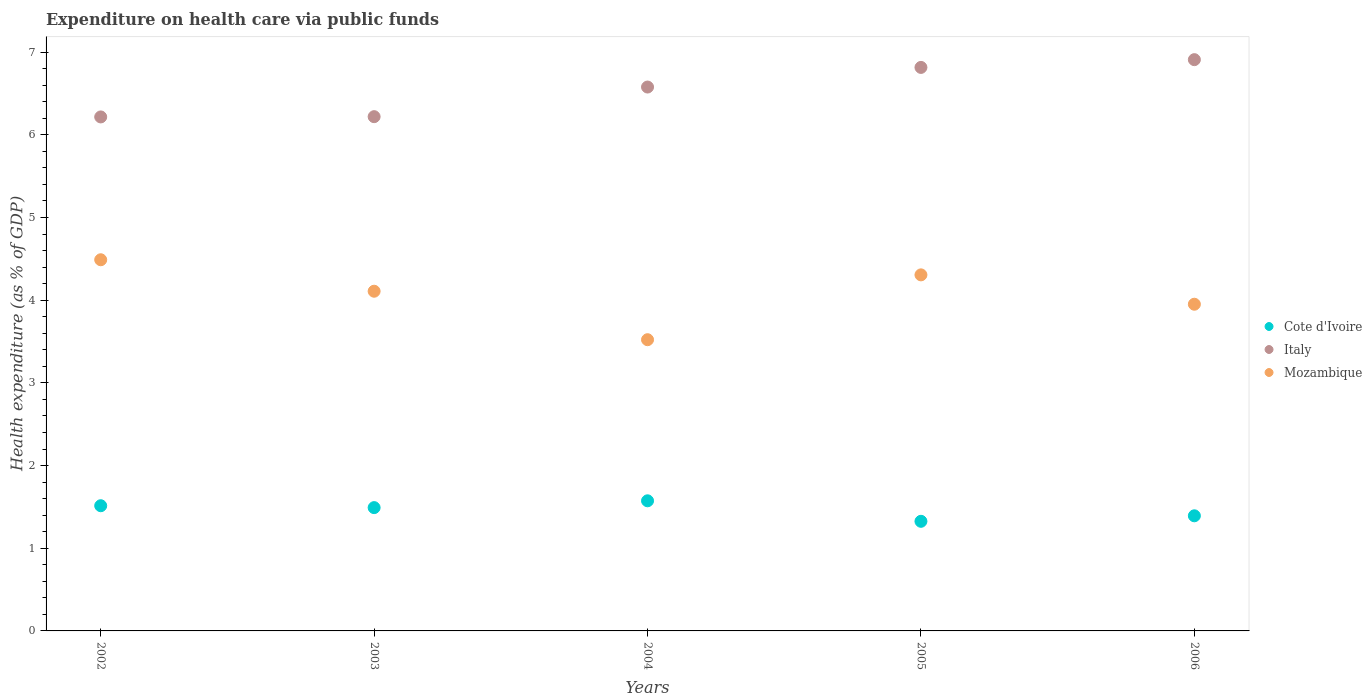Is the number of dotlines equal to the number of legend labels?
Your answer should be compact. Yes. What is the expenditure made on health care in Italy in 2002?
Keep it short and to the point. 6.22. Across all years, what is the maximum expenditure made on health care in Cote d'Ivoire?
Offer a terse response. 1.57. Across all years, what is the minimum expenditure made on health care in Cote d'Ivoire?
Your answer should be compact. 1.33. In which year was the expenditure made on health care in Cote d'Ivoire maximum?
Offer a terse response. 2004. In which year was the expenditure made on health care in Italy minimum?
Provide a short and direct response. 2002. What is the total expenditure made on health care in Mozambique in the graph?
Offer a terse response. 20.38. What is the difference between the expenditure made on health care in Italy in 2002 and that in 2006?
Give a very brief answer. -0.69. What is the difference between the expenditure made on health care in Mozambique in 2004 and the expenditure made on health care in Italy in 2005?
Keep it short and to the point. -3.29. What is the average expenditure made on health care in Italy per year?
Keep it short and to the point. 6.55. In the year 2003, what is the difference between the expenditure made on health care in Cote d'Ivoire and expenditure made on health care in Italy?
Offer a terse response. -4.73. In how many years, is the expenditure made on health care in Mozambique greater than 3 %?
Your answer should be very brief. 5. What is the ratio of the expenditure made on health care in Cote d'Ivoire in 2002 to that in 2006?
Your answer should be very brief. 1.09. Is the difference between the expenditure made on health care in Cote d'Ivoire in 2003 and 2005 greater than the difference between the expenditure made on health care in Italy in 2003 and 2005?
Provide a succinct answer. Yes. What is the difference between the highest and the second highest expenditure made on health care in Mozambique?
Give a very brief answer. 0.18. What is the difference between the highest and the lowest expenditure made on health care in Mozambique?
Your response must be concise. 0.97. In how many years, is the expenditure made on health care in Italy greater than the average expenditure made on health care in Italy taken over all years?
Your response must be concise. 3. Is the sum of the expenditure made on health care in Cote d'Ivoire in 2004 and 2006 greater than the maximum expenditure made on health care in Mozambique across all years?
Your answer should be very brief. No. Does the expenditure made on health care in Cote d'Ivoire monotonically increase over the years?
Provide a succinct answer. No. How many dotlines are there?
Offer a very short reply. 3. Are the values on the major ticks of Y-axis written in scientific E-notation?
Give a very brief answer. No. Does the graph contain grids?
Make the answer very short. No. How many legend labels are there?
Keep it short and to the point. 3. How are the legend labels stacked?
Make the answer very short. Vertical. What is the title of the graph?
Ensure brevity in your answer.  Expenditure on health care via public funds. Does "Brazil" appear as one of the legend labels in the graph?
Your answer should be very brief. No. What is the label or title of the X-axis?
Give a very brief answer. Years. What is the label or title of the Y-axis?
Give a very brief answer. Health expenditure (as % of GDP). What is the Health expenditure (as % of GDP) of Cote d'Ivoire in 2002?
Ensure brevity in your answer.  1.51. What is the Health expenditure (as % of GDP) of Italy in 2002?
Your answer should be compact. 6.22. What is the Health expenditure (as % of GDP) of Mozambique in 2002?
Your answer should be very brief. 4.49. What is the Health expenditure (as % of GDP) in Cote d'Ivoire in 2003?
Make the answer very short. 1.49. What is the Health expenditure (as % of GDP) in Italy in 2003?
Provide a short and direct response. 6.22. What is the Health expenditure (as % of GDP) of Mozambique in 2003?
Keep it short and to the point. 4.11. What is the Health expenditure (as % of GDP) in Cote d'Ivoire in 2004?
Make the answer very short. 1.57. What is the Health expenditure (as % of GDP) of Italy in 2004?
Offer a very short reply. 6.58. What is the Health expenditure (as % of GDP) of Mozambique in 2004?
Offer a very short reply. 3.52. What is the Health expenditure (as % of GDP) of Cote d'Ivoire in 2005?
Ensure brevity in your answer.  1.33. What is the Health expenditure (as % of GDP) in Italy in 2005?
Offer a very short reply. 6.82. What is the Health expenditure (as % of GDP) of Mozambique in 2005?
Offer a terse response. 4.31. What is the Health expenditure (as % of GDP) of Cote d'Ivoire in 2006?
Your answer should be very brief. 1.39. What is the Health expenditure (as % of GDP) of Italy in 2006?
Your answer should be compact. 6.91. What is the Health expenditure (as % of GDP) in Mozambique in 2006?
Make the answer very short. 3.95. Across all years, what is the maximum Health expenditure (as % of GDP) in Cote d'Ivoire?
Offer a terse response. 1.57. Across all years, what is the maximum Health expenditure (as % of GDP) in Italy?
Ensure brevity in your answer.  6.91. Across all years, what is the maximum Health expenditure (as % of GDP) in Mozambique?
Keep it short and to the point. 4.49. Across all years, what is the minimum Health expenditure (as % of GDP) in Cote d'Ivoire?
Make the answer very short. 1.33. Across all years, what is the minimum Health expenditure (as % of GDP) in Italy?
Ensure brevity in your answer.  6.22. Across all years, what is the minimum Health expenditure (as % of GDP) of Mozambique?
Ensure brevity in your answer.  3.52. What is the total Health expenditure (as % of GDP) of Cote d'Ivoire in the graph?
Keep it short and to the point. 7.3. What is the total Health expenditure (as % of GDP) of Italy in the graph?
Provide a succinct answer. 32.74. What is the total Health expenditure (as % of GDP) of Mozambique in the graph?
Keep it short and to the point. 20.38. What is the difference between the Health expenditure (as % of GDP) in Cote d'Ivoire in 2002 and that in 2003?
Keep it short and to the point. 0.02. What is the difference between the Health expenditure (as % of GDP) in Italy in 2002 and that in 2003?
Offer a terse response. -0. What is the difference between the Health expenditure (as % of GDP) in Mozambique in 2002 and that in 2003?
Your answer should be very brief. 0.38. What is the difference between the Health expenditure (as % of GDP) in Cote d'Ivoire in 2002 and that in 2004?
Your answer should be compact. -0.06. What is the difference between the Health expenditure (as % of GDP) of Italy in 2002 and that in 2004?
Make the answer very short. -0.36. What is the difference between the Health expenditure (as % of GDP) of Mozambique in 2002 and that in 2004?
Provide a short and direct response. 0.97. What is the difference between the Health expenditure (as % of GDP) in Cote d'Ivoire in 2002 and that in 2005?
Offer a very short reply. 0.19. What is the difference between the Health expenditure (as % of GDP) of Italy in 2002 and that in 2005?
Keep it short and to the point. -0.6. What is the difference between the Health expenditure (as % of GDP) in Mozambique in 2002 and that in 2005?
Make the answer very short. 0.18. What is the difference between the Health expenditure (as % of GDP) of Cote d'Ivoire in 2002 and that in 2006?
Your response must be concise. 0.12. What is the difference between the Health expenditure (as % of GDP) in Italy in 2002 and that in 2006?
Ensure brevity in your answer.  -0.69. What is the difference between the Health expenditure (as % of GDP) in Mozambique in 2002 and that in 2006?
Your answer should be very brief. 0.54. What is the difference between the Health expenditure (as % of GDP) in Cote d'Ivoire in 2003 and that in 2004?
Ensure brevity in your answer.  -0.08. What is the difference between the Health expenditure (as % of GDP) in Italy in 2003 and that in 2004?
Ensure brevity in your answer.  -0.36. What is the difference between the Health expenditure (as % of GDP) in Mozambique in 2003 and that in 2004?
Provide a succinct answer. 0.59. What is the difference between the Health expenditure (as % of GDP) of Cote d'Ivoire in 2003 and that in 2005?
Offer a very short reply. 0.17. What is the difference between the Health expenditure (as % of GDP) of Italy in 2003 and that in 2005?
Your answer should be compact. -0.6. What is the difference between the Health expenditure (as % of GDP) in Mozambique in 2003 and that in 2005?
Keep it short and to the point. -0.2. What is the difference between the Health expenditure (as % of GDP) of Cote d'Ivoire in 2003 and that in 2006?
Provide a succinct answer. 0.1. What is the difference between the Health expenditure (as % of GDP) of Italy in 2003 and that in 2006?
Ensure brevity in your answer.  -0.69. What is the difference between the Health expenditure (as % of GDP) of Mozambique in 2003 and that in 2006?
Ensure brevity in your answer.  0.16. What is the difference between the Health expenditure (as % of GDP) of Cote d'Ivoire in 2004 and that in 2005?
Provide a succinct answer. 0.25. What is the difference between the Health expenditure (as % of GDP) in Italy in 2004 and that in 2005?
Provide a succinct answer. -0.24. What is the difference between the Health expenditure (as % of GDP) in Mozambique in 2004 and that in 2005?
Offer a very short reply. -0.78. What is the difference between the Health expenditure (as % of GDP) of Cote d'Ivoire in 2004 and that in 2006?
Your response must be concise. 0.18. What is the difference between the Health expenditure (as % of GDP) of Italy in 2004 and that in 2006?
Offer a very short reply. -0.33. What is the difference between the Health expenditure (as % of GDP) of Mozambique in 2004 and that in 2006?
Your answer should be very brief. -0.43. What is the difference between the Health expenditure (as % of GDP) of Cote d'Ivoire in 2005 and that in 2006?
Your response must be concise. -0.07. What is the difference between the Health expenditure (as % of GDP) in Italy in 2005 and that in 2006?
Ensure brevity in your answer.  -0.09. What is the difference between the Health expenditure (as % of GDP) in Mozambique in 2005 and that in 2006?
Your answer should be compact. 0.36. What is the difference between the Health expenditure (as % of GDP) in Cote d'Ivoire in 2002 and the Health expenditure (as % of GDP) in Italy in 2003?
Provide a succinct answer. -4.71. What is the difference between the Health expenditure (as % of GDP) in Cote d'Ivoire in 2002 and the Health expenditure (as % of GDP) in Mozambique in 2003?
Ensure brevity in your answer.  -2.59. What is the difference between the Health expenditure (as % of GDP) of Italy in 2002 and the Health expenditure (as % of GDP) of Mozambique in 2003?
Provide a short and direct response. 2.11. What is the difference between the Health expenditure (as % of GDP) of Cote d'Ivoire in 2002 and the Health expenditure (as % of GDP) of Italy in 2004?
Your response must be concise. -5.06. What is the difference between the Health expenditure (as % of GDP) in Cote d'Ivoire in 2002 and the Health expenditure (as % of GDP) in Mozambique in 2004?
Keep it short and to the point. -2.01. What is the difference between the Health expenditure (as % of GDP) in Italy in 2002 and the Health expenditure (as % of GDP) in Mozambique in 2004?
Offer a very short reply. 2.69. What is the difference between the Health expenditure (as % of GDP) of Cote d'Ivoire in 2002 and the Health expenditure (as % of GDP) of Italy in 2005?
Ensure brevity in your answer.  -5.3. What is the difference between the Health expenditure (as % of GDP) in Cote d'Ivoire in 2002 and the Health expenditure (as % of GDP) in Mozambique in 2005?
Your answer should be very brief. -2.79. What is the difference between the Health expenditure (as % of GDP) in Italy in 2002 and the Health expenditure (as % of GDP) in Mozambique in 2005?
Your answer should be very brief. 1.91. What is the difference between the Health expenditure (as % of GDP) of Cote d'Ivoire in 2002 and the Health expenditure (as % of GDP) of Italy in 2006?
Your answer should be compact. -5.39. What is the difference between the Health expenditure (as % of GDP) in Cote d'Ivoire in 2002 and the Health expenditure (as % of GDP) in Mozambique in 2006?
Give a very brief answer. -2.44. What is the difference between the Health expenditure (as % of GDP) in Italy in 2002 and the Health expenditure (as % of GDP) in Mozambique in 2006?
Your answer should be very brief. 2.27. What is the difference between the Health expenditure (as % of GDP) in Cote d'Ivoire in 2003 and the Health expenditure (as % of GDP) in Italy in 2004?
Provide a succinct answer. -5.09. What is the difference between the Health expenditure (as % of GDP) of Cote d'Ivoire in 2003 and the Health expenditure (as % of GDP) of Mozambique in 2004?
Your answer should be very brief. -2.03. What is the difference between the Health expenditure (as % of GDP) in Italy in 2003 and the Health expenditure (as % of GDP) in Mozambique in 2004?
Ensure brevity in your answer.  2.7. What is the difference between the Health expenditure (as % of GDP) of Cote d'Ivoire in 2003 and the Health expenditure (as % of GDP) of Italy in 2005?
Offer a terse response. -5.32. What is the difference between the Health expenditure (as % of GDP) in Cote d'Ivoire in 2003 and the Health expenditure (as % of GDP) in Mozambique in 2005?
Ensure brevity in your answer.  -2.81. What is the difference between the Health expenditure (as % of GDP) in Italy in 2003 and the Health expenditure (as % of GDP) in Mozambique in 2005?
Your answer should be very brief. 1.91. What is the difference between the Health expenditure (as % of GDP) of Cote d'Ivoire in 2003 and the Health expenditure (as % of GDP) of Italy in 2006?
Your answer should be compact. -5.42. What is the difference between the Health expenditure (as % of GDP) in Cote d'Ivoire in 2003 and the Health expenditure (as % of GDP) in Mozambique in 2006?
Make the answer very short. -2.46. What is the difference between the Health expenditure (as % of GDP) in Italy in 2003 and the Health expenditure (as % of GDP) in Mozambique in 2006?
Your answer should be very brief. 2.27. What is the difference between the Health expenditure (as % of GDP) of Cote d'Ivoire in 2004 and the Health expenditure (as % of GDP) of Italy in 2005?
Offer a terse response. -5.24. What is the difference between the Health expenditure (as % of GDP) in Cote d'Ivoire in 2004 and the Health expenditure (as % of GDP) in Mozambique in 2005?
Offer a terse response. -2.73. What is the difference between the Health expenditure (as % of GDP) of Italy in 2004 and the Health expenditure (as % of GDP) of Mozambique in 2005?
Make the answer very short. 2.27. What is the difference between the Health expenditure (as % of GDP) in Cote d'Ivoire in 2004 and the Health expenditure (as % of GDP) in Italy in 2006?
Give a very brief answer. -5.34. What is the difference between the Health expenditure (as % of GDP) of Cote d'Ivoire in 2004 and the Health expenditure (as % of GDP) of Mozambique in 2006?
Your response must be concise. -2.38. What is the difference between the Health expenditure (as % of GDP) of Italy in 2004 and the Health expenditure (as % of GDP) of Mozambique in 2006?
Offer a terse response. 2.63. What is the difference between the Health expenditure (as % of GDP) in Cote d'Ivoire in 2005 and the Health expenditure (as % of GDP) in Italy in 2006?
Provide a short and direct response. -5.58. What is the difference between the Health expenditure (as % of GDP) in Cote d'Ivoire in 2005 and the Health expenditure (as % of GDP) in Mozambique in 2006?
Give a very brief answer. -2.63. What is the difference between the Health expenditure (as % of GDP) in Italy in 2005 and the Health expenditure (as % of GDP) in Mozambique in 2006?
Keep it short and to the point. 2.86. What is the average Health expenditure (as % of GDP) in Cote d'Ivoire per year?
Your answer should be compact. 1.46. What is the average Health expenditure (as % of GDP) of Italy per year?
Provide a succinct answer. 6.55. What is the average Health expenditure (as % of GDP) in Mozambique per year?
Your response must be concise. 4.08. In the year 2002, what is the difference between the Health expenditure (as % of GDP) in Cote d'Ivoire and Health expenditure (as % of GDP) in Italy?
Offer a terse response. -4.7. In the year 2002, what is the difference between the Health expenditure (as % of GDP) of Cote d'Ivoire and Health expenditure (as % of GDP) of Mozambique?
Provide a short and direct response. -2.97. In the year 2002, what is the difference between the Health expenditure (as % of GDP) of Italy and Health expenditure (as % of GDP) of Mozambique?
Offer a terse response. 1.73. In the year 2003, what is the difference between the Health expenditure (as % of GDP) of Cote d'Ivoire and Health expenditure (as % of GDP) of Italy?
Your answer should be very brief. -4.73. In the year 2003, what is the difference between the Health expenditure (as % of GDP) in Cote d'Ivoire and Health expenditure (as % of GDP) in Mozambique?
Offer a terse response. -2.62. In the year 2003, what is the difference between the Health expenditure (as % of GDP) in Italy and Health expenditure (as % of GDP) in Mozambique?
Provide a succinct answer. 2.11. In the year 2004, what is the difference between the Health expenditure (as % of GDP) of Cote d'Ivoire and Health expenditure (as % of GDP) of Italy?
Provide a short and direct response. -5. In the year 2004, what is the difference between the Health expenditure (as % of GDP) of Cote d'Ivoire and Health expenditure (as % of GDP) of Mozambique?
Your answer should be compact. -1.95. In the year 2004, what is the difference between the Health expenditure (as % of GDP) in Italy and Health expenditure (as % of GDP) in Mozambique?
Ensure brevity in your answer.  3.06. In the year 2005, what is the difference between the Health expenditure (as % of GDP) of Cote d'Ivoire and Health expenditure (as % of GDP) of Italy?
Make the answer very short. -5.49. In the year 2005, what is the difference between the Health expenditure (as % of GDP) in Cote d'Ivoire and Health expenditure (as % of GDP) in Mozambique?
Make the answer very short. -2.98. In the year 2005, what is the difference between the Health expenditure (as % of GDP) in Italy and Health expenditure (as % of GDP) in Mozambique?
Provide a succinct answer. 2.51. In the year 2006, what is the difference between the Health expenditure (as % of GDP) in Cote d'Ivoire and Health expenditure (as % of GDP) in Italy?
Give a very brief answer. -5.52. In the year 2006, what is the difference between the Health expenditure (as % of GDP) in Cote d'Ivoire and Health expenditure (as % of GDP) in Mozambique?
Offer a very short reply. -2.56. In the year 2006, what is the difference between the Health expenditure (as % of GDP) in Italy and Health expenditure (as % of GDP) in Mozambique?
Provide a short and direct response. 2.96. What is the ratio of the Health expenditure (as % of GDP) of Cote d'Ivoire in 2002 to that in 2003?
Make the answer very short. 1.02. What is the ratio of the Health expenditure (as % of GDP) in Mozambique in 2002 to that in 2003?
Ensure brevity in your answer.  1.09. What is the ratio of the Health expenditure (as % of GDP) in Cote d'Ivoire in 2002 to that in 2004?
Make the answer very short. 0.96. What is the ratio of the Health expenditure (as % of GDP) of Italy in 2002 to that in 2004?
Offer a terse response. 0.94. What is the ratio of the Health expenditure (as % of GDP) in Mozambique in 2002 to that in 2004?
Keep it short and to the point. 1.27. What is the ratio of the Health expenditure (as % of GDP) of Cote d'Ivoire in 2002 to that in 2005?
Ensure brevity in your answer.  1.14. What is the ratio of the Health expenditure (as % of GDP) in Italy in 2002 to that in 2005?
Make the answer very short. 0.91. What is the ratio of the Health expenditure (as % of GDP) of Mozambique in 2002 to that in 2005?
Offer a terse response. 1.04. What is the ratio of the Health expenditure (as % of GDP) of Cote d'Ivoire in 2002 to that in 2006?
Make the answer very short. 1.09. What is the ratio of the Health expenditure (as % of GDP) of Italy in 2002 to that in 2006?
Keep it short and to the point. 0.9. What is the ratio of the Health expenditure (as % of GDP) in Mozambique in 2002 to that in 2006?
Offer a terse response. 1.14. What is the ratio of the Health expenditure (as % of GDP) in Cote d'Ivoire in 2003 to that in 2004?
Provide a succinct answer. 0.95. What is the ratio of the Health expenditure (as % of GDP) of Italy in 2003 to that in 2004?
Provide a short and direct response. 0.95. What is the ratio of the Health expenditure (as % of GDP) in Mozambique in 2003 to that in 2004?
Your answer should be compact. 1.17. What is the ratio of the Health expenditure (as % of GDP) in Cote d'Ivoire in 2003 to that in 2005?
Your response must be concise. 1.12. What is the ratio of the Health expenditure (as % of GDP) in Italy in 2003 to that in 2005?
Provide a succinct answer. 0.91. What is the ratio of the Health expenditure (as % of GDP) in Mozambique in 2003 to that in 2005?
Give a very brief answer. 0.95. What is the ratio of the Health expenditure (as % of GDP) in Cote d'Ivoire in 2003 to that in 2006?
Make the answer very short. 1.07. What is the ratio of the Health expenditure (as % of GDP) in Italy in 2003 to that in 2006?
Ensure brevity in your answer.  0.9. What is the ratio of the Health expenditure (as % of GDP) of Mozambique in 2003 to that in 2006?
Your response must be concise. 1.04. What is the ratio of the Health expenditure (as % of GDP) in Cote d'Ivoire in 2004 to that in 2005?
Your answer should be very brief. 1.19. What is the ratio of the Health expenditure (as % of GDP) of Italy in 2004 to that in 2005?
Your answer should be very brief. 0.97. What is the ratio of the Health expenditure (as % of GDP) of Mozambique in 2004 to that in 2005?
Your response must be concise. 0.82. What is the ratio of the Health expenditure (as % of GDP) of Cote d'Ivoire in 2004 to that in 2006?
Make the answer very short. 1.13. What is the ratio of the Health expenditure (as % of GDP) of Italy in 2004 to that in 2006?
Provide a short and direct response. 0.95. What is the ratio of the Health expenditure (as % of GDP) of Mozambique in 2004 to that in 2006?
Ensure brevity in your answer.  0.89. What is the ratio of the Health expenditure (as % of GDP) in Cote d'Ivoire in 2005 to that in 2006?
Your answer should be compact. 0.95. What is the ratio of the Health expenditure (as % of GDP) in Italy in 2005 to that in 2006?
Keep it short and to the point. 0.99. What is the ratio of the Health expenditure (as % of GDP) in Mozambique in 2005 to that in 2006?
Ensure brevity in your answer.  1.09. What is the difference between the highest and the second highest Health expenditure (as % of GDP) in Cote d'Ivoire?
Make the answer very short. 0.06. What is the difference between the highest and the second highest Health expenditure (as % of GDP) in Italy?
Offer a terse response. 0.09. What is the difference between the highest and the second highest Health expenditure (as % of GDP) of Mozambique?
Offer a terse response. 0.18. What is the difference between the highest and the lowest Health expenditure (as % of GDP) of Cote d'Ivoire?
Your answer should be very brief. 0.25. What is the difference between the highest and the lowest Health expenditure (as % of GDP) of Italy?
Provide a short and direct response. 0.69. What is the difference between the highest and the lowest Health expenditure (as % of GDP) in Mozambique?
Provide a short and direct response. 0.97. 